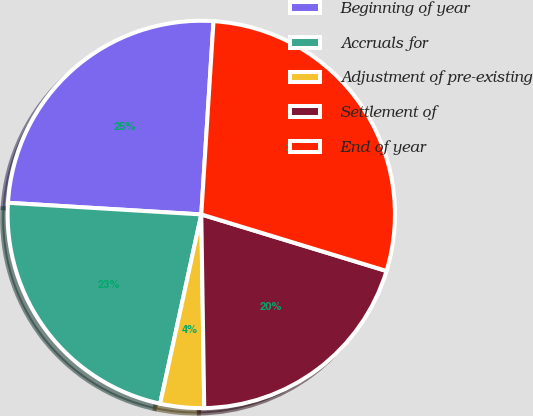<chart> <loc_0><loc_0><loc_500><loc_500><pie_chart><fcel>Beginning of year<fcel>Accruals for<fcel>Adjustment of pre-existing<fcel>Settlement of<fcel>End of year<nl><fcel>25.05%<fcel>22.55%<fcel>3.65%<fcel>20.04%<fcel>28.71%<nl></chart> 